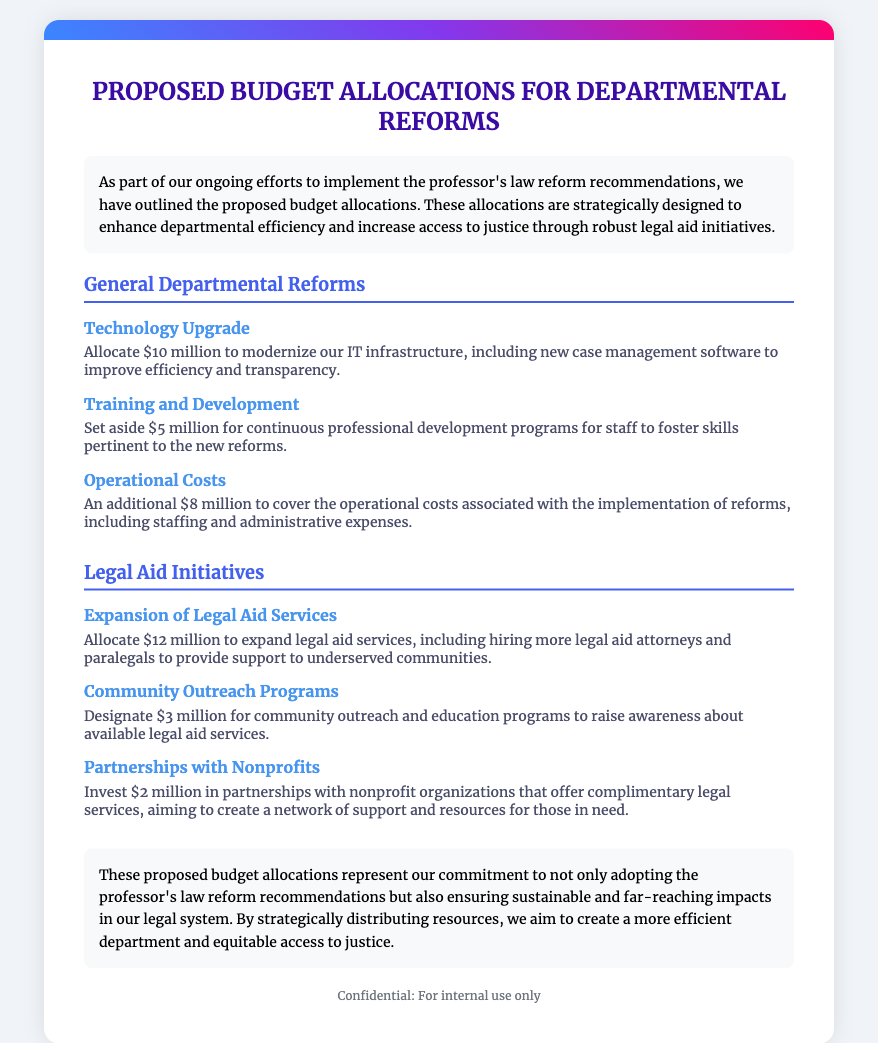What is the title of the document? The title of the document appears at the top of the envelope.
Answer: Proposed Budget Allocations for Departmental Reforms How much is allocated for Technology Upgrade? This allocation is found in the General Departmental Reforms section.
Answer: $10 million What is the purpose of the $3 million community outreach allocation? The description provides insight into the purpose of this funding.
Answer: Raise awareness about available legal aid services How many areas are covered under General Departmental Reforms? The document lists multiple items under this section.
Answer: Three What is the total budget allocated for Legal Aid Initiatives? This requires adding the allocated amounts listed in the Legal Aid Initiatives section.
Answer: $17 million Which item is the highest funded in the proposed budget allocations? The document specifies the amounts allocated for each item.
Answer: Expansion of Legal Aid Services What type of professional development is funded by $5 million? This information relates to the purpose of the allocated funds in the General Departmental Reforms section.
Answer: Continuous professional development programs What is the concluding message of the document? This reflects the overarching goals presented in the conclusion section.
Answer: Commitment to adopting the professor's law reform recommendations How much is allocated for partnerships with nonprofits? This can be found in the Legal Aid Initiatives section.
Answer: $2 million 